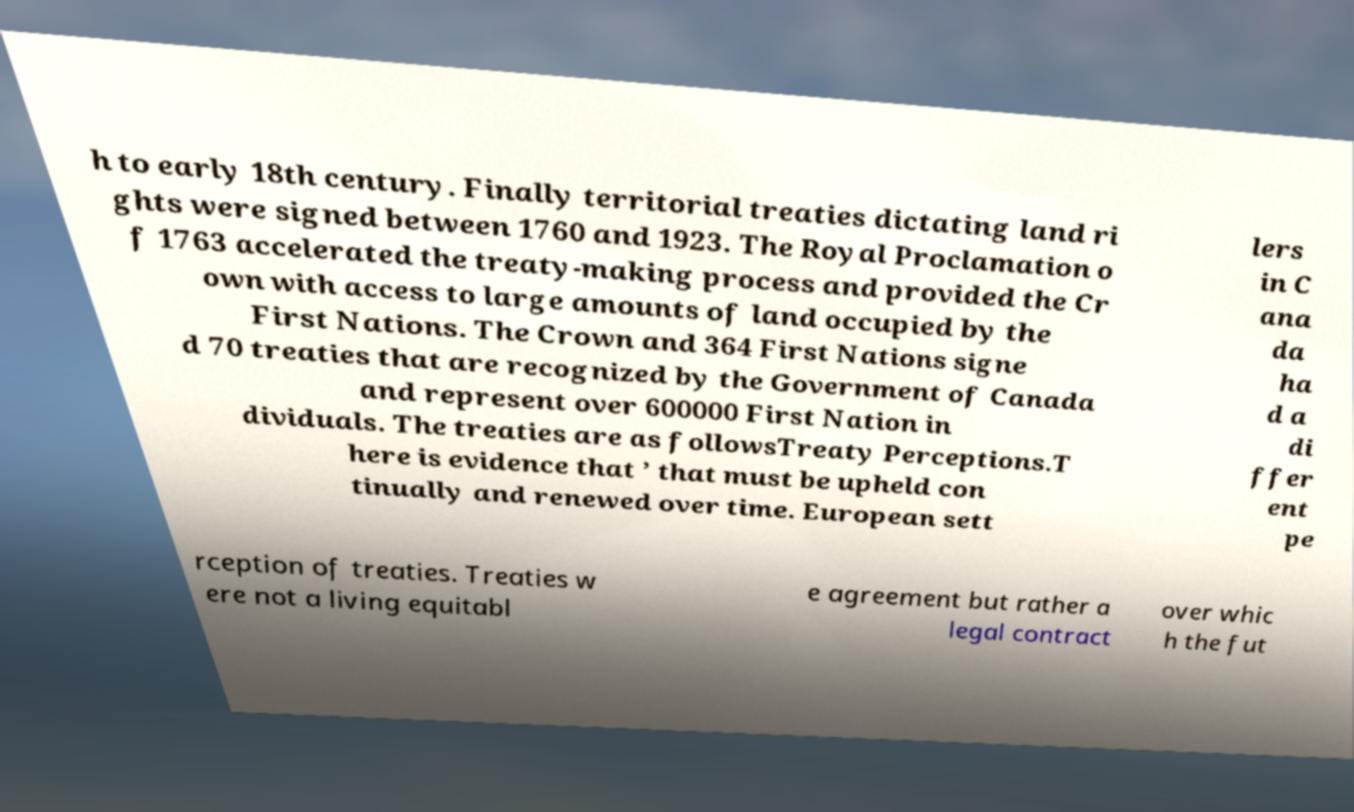Can you accurately transcribe the text from the provided image for me? h to early 18th century. Finally territorial treaties dictating land ri ghts were signed between 1760 and 1923. The Royal Proclamation o f 1763 accelerated the treaty-making process and provided the Cr own with access to large amounts of land occupied by the First Nations. The Crown and 364 First Nations signe d 70 treaties that are recognized by the Government of Canada and represent over 600000 First Nation in dividuals. The treaties are as followsTreaty Perceptions.T here is evidence that ’ that must be upheld con tinually and renewed over time. European sett lers in C ana da ha d a di ffer ent pe rception of treaties. Treaties w ere not a living equitabl e agreement but rather a legal contract over whic h the fut 